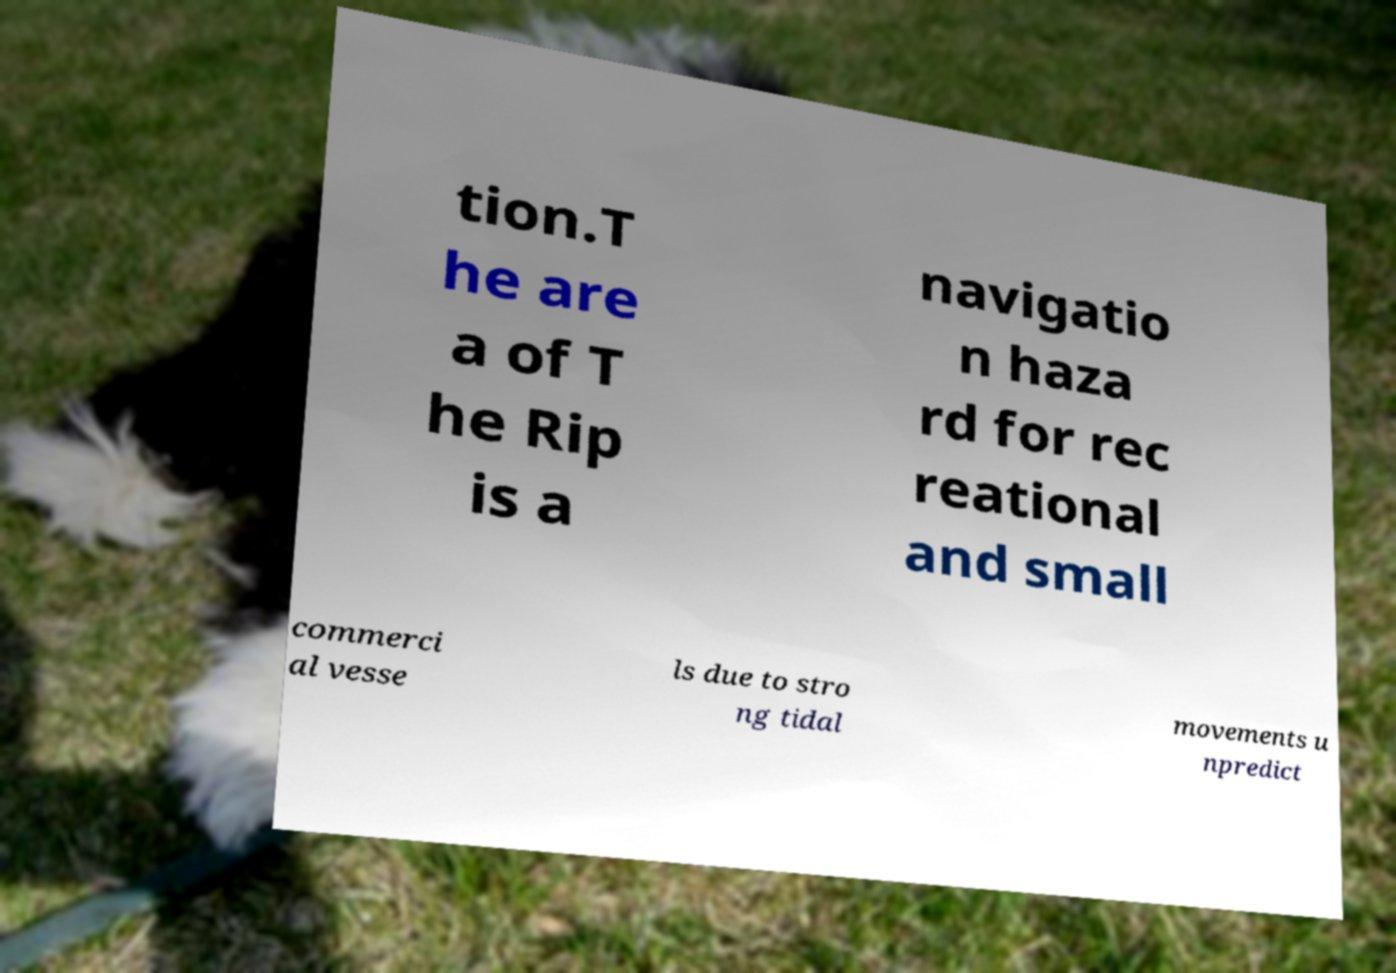Can you read and provide the text displayed in the image?This photo seems to have some interesting text. Can you extract and type it out for me? tion.T he are a of T he Rip is a navigatio n haza rd for rec reational and small commerci al vesse ls due to stro ng tidal movements u npredict 